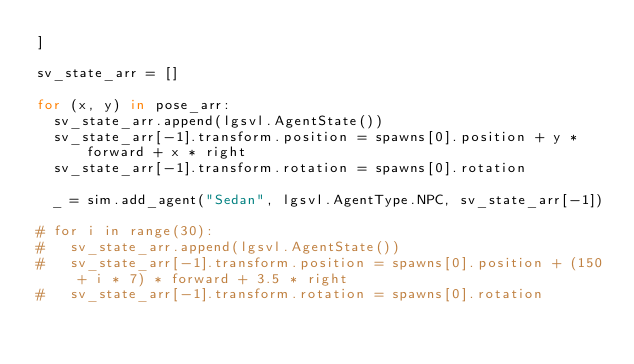Convert code to text. <code><loc_0><loc_0><loc_500><loc_500><_Python_>]

sv_state_arr = []

for (x, y) in pose_arr:
  sv_state_arr.append(lgsvl.AgentState())
  sv_state_arr[-1].transform.position = spawns[0].position + y * forward + x * right
  sv_state_arr[-1].transform.rotation = spawns[0].rotation

  _ = sim.add_agent("Sedan", lgsvl.AgentType.NPC, sv_state_arr[-1])

# for i in range(30):
#   sv_state_arr.append(lgsvl.AgentState())
#   sv_state_arr[-1].transform.position = spawns[0].position + (150 + i * 7) * forward + 3.5 * right
#   sv_state_arr[-1].transform.rotation = spawns[0].rotation
</code> 